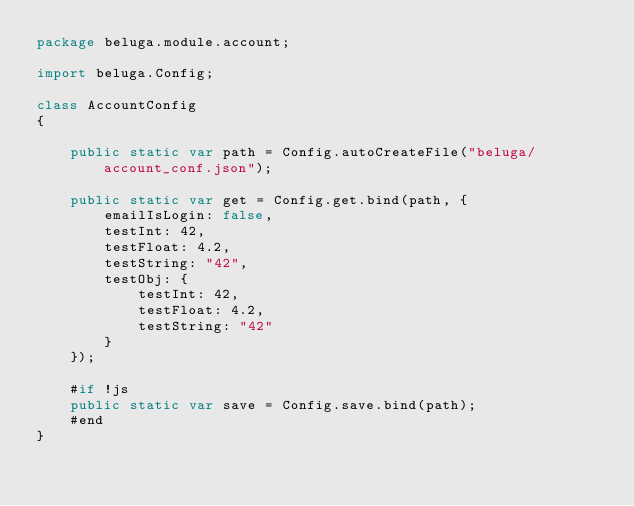Convert code to text. <code><loc_0><loc_0><loc_500><loc_500><_Haxe_>package beluga.module.account;

import beluga.Config;

class AccountConfig
{

    public static var path = Config.autoCreateFile("beluga/account_conf.json");

    public static var get = Config.get.bind(path, {
        emailIsLogin: false,
        testInt: 42,
        testFloat: 4.2,
        testString: "42",
        testObj: {
            testInt: 42,
            testFloat: 4.2,
            testString: "42"
        }
    });

    #if !js
    public static var save = Config.save.bind(path);
    #end
}</code> 